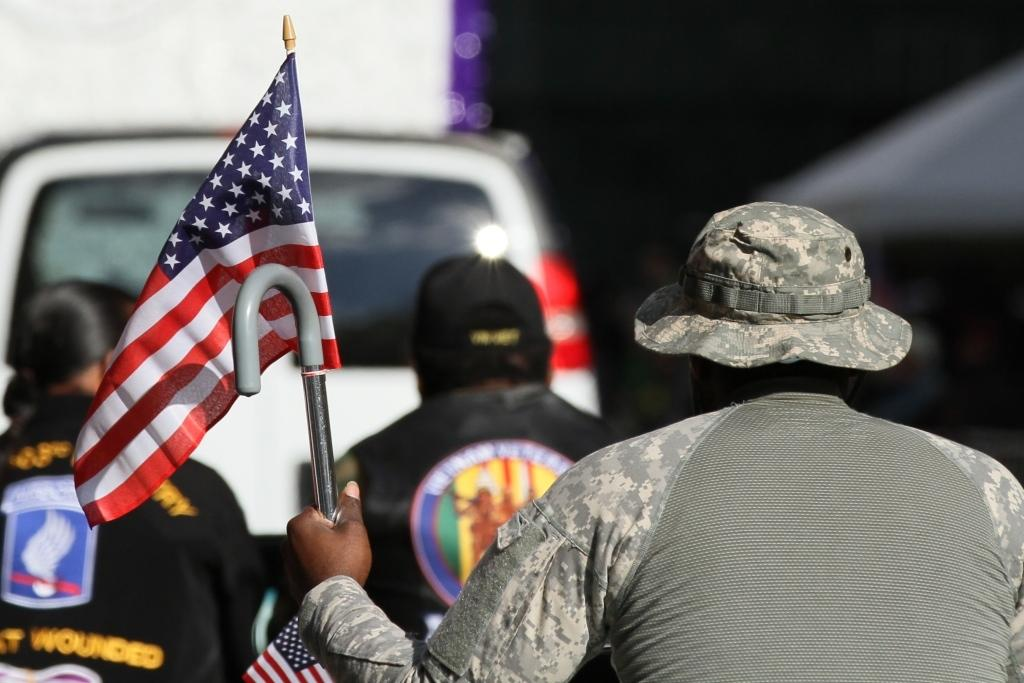What is the person in the image holding? The person in the image is holding a flag. Can you describe the person's attire? The person is wearing a cap. What are the people in the background wearing? The people in the background are wearing jackets and dresses. What else can be seen in the background? There is a vehicle visible in the background. What type of pickle is the actor holding in the image? There is no actor or pickle present in the image. What idea does the person holding the flag represent in the image? The image does not provide any information about the idea or representation of the person holding the flag. 